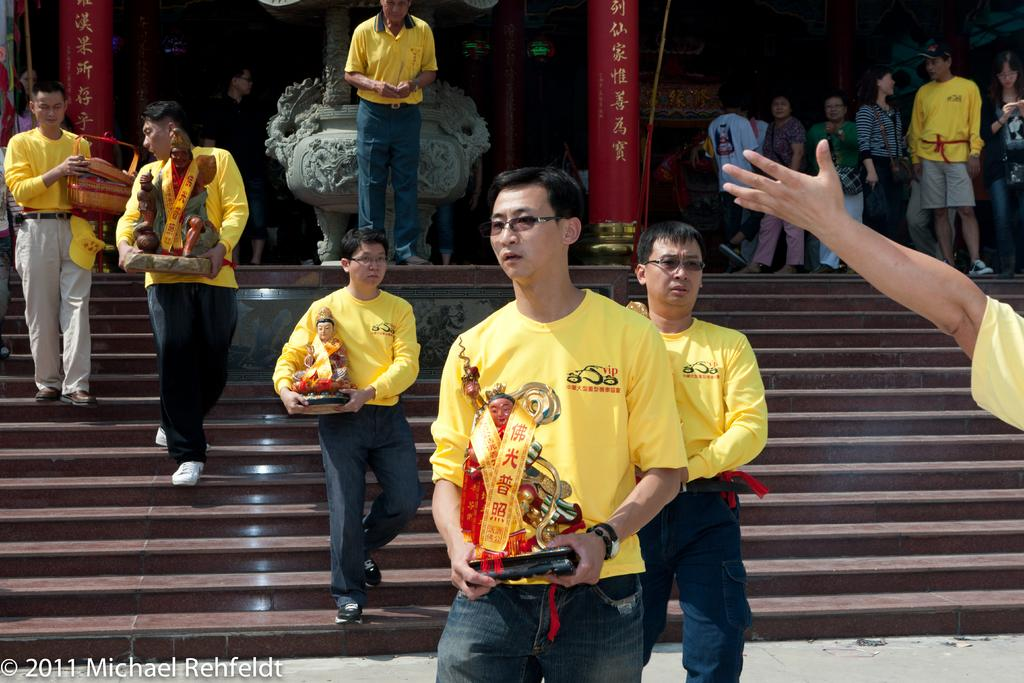What are the people in the image doing? Some people are standing, and others are walking in the image. What are the people holding in their hands? The people are holding idols in their hands. What architectural features can be seen in the image? There are stairs and pillars in the image. What type of tin can be seen being filled with water from a pail in the image? There is no tin or pail present in the image; the people are holding idols in their hands. 